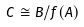Convert formula to latex. <formula><loc_0><loc_0><loc_500><loc_500>C \cong B / f ( A )</formula> 